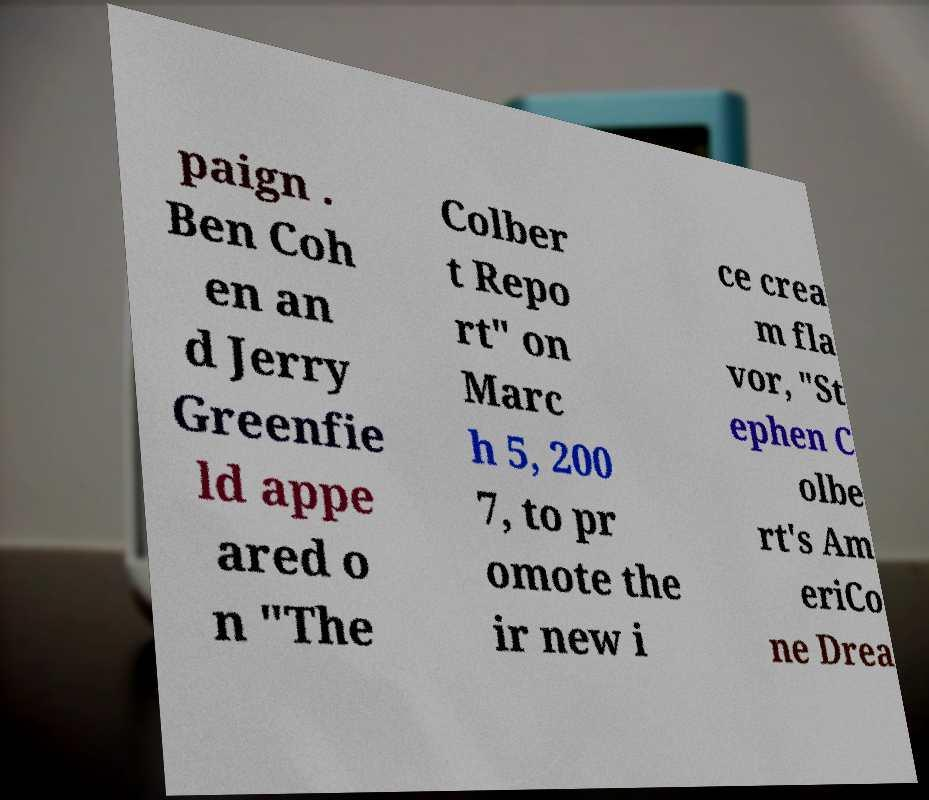Can you accurately transcribe the text from the provided image for me? paign . Ben Coh en an d Jerry Greenfie ld appe ared o n "The Colber t Repo rt" on Marc h 5, 200 7, to pr omote the ir new i ce crea m fla vor, "St ephen C olbe rt's Am eriCo ne Drea 